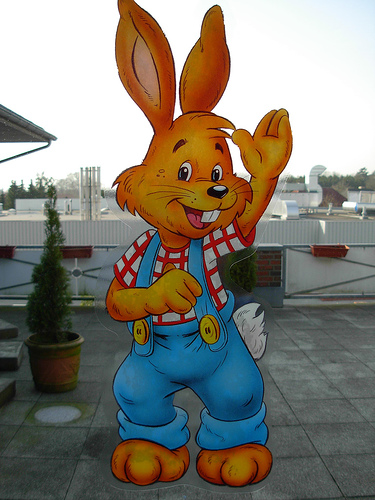<image>
Is the pants on the rabbit? Yes. Looking at the image, I can see the pants is positioned on top of the rabbit, with the rabbit providing support. Where is the bunny in relation to the overalls? Is it above the overalls? No. The bunny is not positioned above the overalls. The vertical arrangement shows a different relationship. 